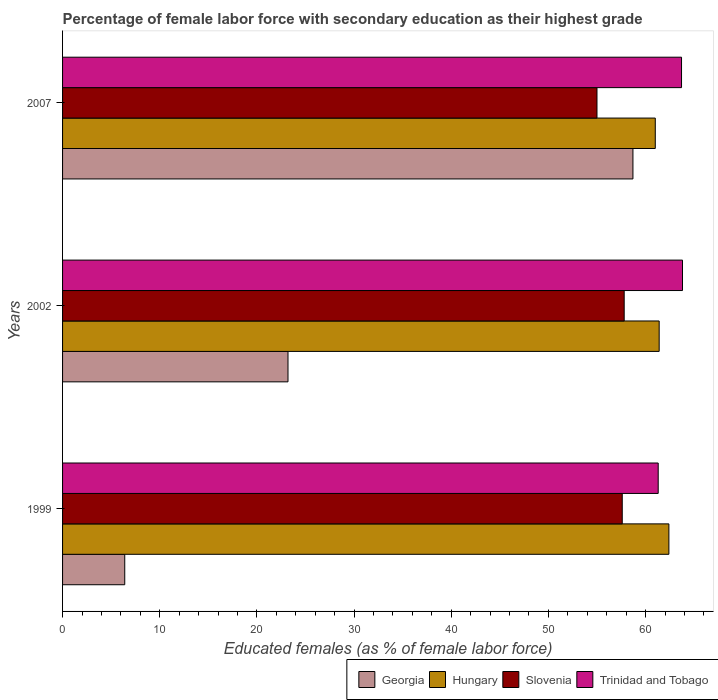How many groups of bars are there?
Your answer should be very brief. 3. Are the number of bars per tick equal to the number of legend labels?
Provide a short and direct response. Yes. Are the number of bars on each tick of the Y-axis equal?
Make the answer very short. Yes. How many bars are there on the 1st tick from the bottom?
Your answer should be compact. 4. What is the percentage of female labor force with secondary education in Trinidad and Tobago in 2007?
Your response must be concise. 63.7. Across all years, what is the maximum percentage of female labor force with secondary education in Hungary?
Your answer should be compact. 62.4. In which year was the percentage of female labor force with secondary education in Slovenia maximum?
Your response must be concise. 2002. What is the total percentage of female labor force with secondary education in Slovenia in the graph?
Provide a succinct answer. 170.4. What is the difference between the percentage of female labor force with secondary education in Hungary in 1999 and that in 2007?
Offer a terse response. 1.4. What is the difference between the percentage of female labor force with secondary education in Slovenia in 2007 and the percentage of female labor force with secondary education in Hungary in 1999?
Give a very brief answer. -7.4. What is the average percentage of female labor force with secondary education in Hungary per year?
Keep it short and to the point. 61.6. In the year 2007, what is the difference between the percentage of female labor force with secondary education in Georgia and percentage of female labor force with secondary education in Slovenia?
Keep it short and to the point. 3.7. What is the ratio of the percentage of female labor force with secondary education in Georgia in 2002 to that in 2007?
Offer a terse response. 0.4. Is the percentage of female labor force with secondary education in Slovenia in 2002 less than that in 2007?
Give a very brief answer. No. What is the difference between the highest and the second highest percentage of female labor force with secondary education in Slovenia?
Provide a succinct answer. 0.2. In how many years, is the percentage of female labor force with secondary education in Georgia greater than the average percentage of female labor force with secondary education in Georgia taken over all years?
Your answer should be compact. 1. Is the sum of the percentage of female labor force with secondary education in Trinidad and Tobago in 2002 and 2007 greater than the maximum percentage of female labor force with secondary education in Georgia across all years?
Your answer should be very brief. Yes. Is it the case that in every year, the sum of the percentage of female labor force with secondary education in Georgia and percentage of female labor force with secondary education in Hungary is greater than the sum of percentage of female labor force with secondary education in Slovenia and percentage of female labor force with secondary education in Trinidad and Tobago?
Provide a short and direct response. No. What does the 4th bar from the top in 1999 represents?
Offer a very short reply. Georgia. What does the 4th bar from the bottom in 1999 represents?
Give a very brief answer. Trinidad and Tobago. How many bars are there?
Ensure brevity in your answer.  12. Are all the bars in the graph horizontal?
Your answer should be compact. Yes. How many years are there in the graph?
Keep it short and to the point. 3. What is the difference between two consecutive major ticks on the X-axis?
Keep it short and to the point. 10. Are the values on the major ticks of X-axis written in scientific E-notation?
Make the answer very short. No. Where does the legend appear in the graph?
Give a very brief answer. Bottom right. How many legend labels are there?
Ensure brevity in your answer.  4. How are the legend labels stacked?
Offer a terse response. Horizontal. What is the title of the graph?
Your answer should be very brief. Percentage of female labor force with secondary education as their highest grade. Does "Cyprus" appear as one of the legend labels in the graph?
Provide a succinct answer. No. What is the label or title of the X-axis?
Your response must be concise. Educated females (as % of female labor force). What is the label or title of the Y-axis?
Your answer should be very brief. Years. What is the Educated females (as % of female labor force) in Georgia in 1999?
Provide a short and direct response. 6.4. What is the Educated females (as % of female labor force) of Hungary in 1999?
Provide a short and direct response. 62.4. What is the Educated females (as % of female labor force) of Slovenia in 1999?
Provide a short and direct response. 57.6. What is the Educated females (as % of female labor force) of Trinidad and Tobago in 1999?
Your answer should be very brief. 61.3. What is the Educated females (as % of female labor force) in Georgia in 2002?
Give a very brief answer. 23.2. What is the Educated females (as % of female labor force) of Hungary in 2002?
Offer a terse response. 61.4. What is the Educated females (as % of female labor force) in Slovenia in 2002?
Provide a succinct answer. 57.8. What is the Educated females (as % of female labor force) of Trinidad and Tobago in 2002?
Provide a short and direct response. 63.8. What is the Educated females (as % of female labor force) of Georgia in 2007?
Provide a short and direct response. 58.7. What is the Educated females (as % of female labor force) of Trinidad and Tobago in 2007?
Give a very brief answer. 63.7. Across all years, what is the maximum Educated females (as % of female labor force) in Georgia?
Give a very brief answer. 58.7. Across all years, what is the maximum Educated females (as % of female labor force) in Hungary?
Make the answer very short. 62.4. Across all years, what is the maximum Educated females (as % of female labor force) in Slovenia?
Your answer should be compact. 57.8. Across all years, what is the maximum Educated females (as % of female labor force) of Trinidad and Tobago?
Provide a succinct answer. 63.8. Across all years, what is the minimum Educated females (as % of female labor force) of Georgia?
Provide a short and direct response. 6.4. Across all years, what is the minimum Educated females (as % of female labor force) of Hungary?
Provide a succinct answer. 61. Across all years, what is the minimum Educated females (as % of female labor force) of Slovenia?
Your answer should be very brief. 55. Across all years, what is the minimum Educated females (as % of female labor force) in Trinidad and Tobago?
Provide a short and direct response. 61.3. What is the total Educated females (as % of female labor force) of Georgia in the graph?
Your answer should be very brief. 88.3. What is the total Educated females (as % of female labor force) in Hungary in the graph?
Your answer should be compact. 184.8. What is the total Educated females (as % of female labor force) in Slovenia in the graph?
Your answer should be compact. 170.4. What is the total Educated females (as % of female labor force) in Trinidad and Tobago in the graph?
Your answer should be compact. 188.8. What is the difference between the Educated females (as % of female labor force) of Georgia in 1999 and that in 2002?
Keep it short and to the point. -16.8. What is the difference between the Educated females (as % of female labor force) in Georgia in 1999 and that in 2007?
Offer a very short reply. -52.3. What is the difference between the Educated females (as % of female labor force) in Trinidad and Tobago in 1999 and that in 2007?
Your answer should be compact. -2.4. What is the difference between the Educated females (as % of female labor force) in Georgia in 2002 and that in 2007?
Keep it short and to the point. -35.5. What is the difference between the Educated females (as % of female labor force) of Slovenia in 2002 and that in 2007?
Your answer should be very brief. 2.8. What is the difference between the Educated females (as % of female labor force) in Trinidad and Tobago in 2002 and that in 2007?
Make the answer very short. 0.1. What is the difference between the Educated females (as % of female labor force) of Georgia in 1999 and the Educated females (as % of female labor force) of Hungary in 2002?
Make the answer very short. -55. What is the difference between the Educated females (as % of female labor force) in Georgia in 1999 and the Educated females (as % of female labor force) in Slovenia in 2002?
Provide a succinct answer. -51.4. What is the difference between the Educated females (as % of female labor force) of Georgia in 1999 and the Educated females (as % of female labor force) of Trinidad and Tobago in 2002?
Offer a terse response. -57.4. What is the difference between the Educated females (as % of female labor force) in Hungary in 1999 and the Educated females (as % of female labor force) in Trinidad and Tobago in 2002?
Give a very brief answer. -1.4. What is the difference between the Educated females (as % of female labor force) in Georgia in 1999 and the Educated females (as % of female labor force) in Hungary in 2007?
Keep it short and to the point. -54.6. What is the difference between the Educated females (as % of female labor force) of Georgia in 1999 and the Educated females (as % of female labor force) of Slovenia in 2007?
Offer a very short reply. -48.6. What is the difference between the Educated females (as % of female labor force) in Georgia in 1999 and the Educated females (as % of female labor force) in Trinidad and Tobago in 2007?
Provide a succinct answer. -57.3. What is the difference between the Educated females (as % of female labor force) in Hungary in 1999 and the Educated females (as % of female labor force) in Slovenia in 2007?
Provide a succinct answer. 7.4. What is the difference between the Educated females (as % of female labor force) of Georgia in 2002 and the Educated females (as % of female labor force) of Hungary in 2007?
Provide a succinct answer. -37.8. What is the difference between the Educated females (as % of female labor force) of Georgia in 2002 and the Educated females (as % of female labor force) of Slovenia in 2007?
Provide a short and direct response. -31.8. What is the difference between the Educated females (as % of female labor force) in Georgia in 2002 and the Educated females (as % of female labor force) in Trinidad and Tobago in 2007?
Your response must be concise. -40.5. What is the difference between the Educated females (as % of female labor force) in Hungary in 2002 and the Educated females (as % of female labor force) in Trinidad and Tobago in 2007?
Your answer should be very brief. -2.3. What is the difference between the Educated females (as % of female labor force) of Slovenia in 2002 and the Educated females (as % of female labor force) of Trinidad and Tobago in 2007?
Offer a terse response. -5.9. What is the average Educated females (as % of female labor force) in Georgia per year?
Give a very brief answer. 29.43. What is the average Educated females (as % of female labor force) of Hungary per year?
Your response must be concise. 61.6. What is the average Educated females (as % of female labor force) of Slovenia per year?
Make the answer very short. 56.8. What is the average Educated females (as % of female labor force) in Trinidad and Tobago per year?
Provide a succinct answer. 62.93. In the year 1999, what is the difference between the Educated females (as % of female labor force) in Georgia and Educated females (as % of female labor force) in Hungary?
Your answer should be compact. -56. In the year 1999, what is the difference between the Educated females (as % of female labor force) in Georgia and Educated females (as % of female labor force) in Slovenia?
Give a very brief answer. -51.2. In the year 1999, what is the difference between the Educated females (as % of female labor force) of Georgia and Educated females (as % of female labor force) of Trinidad and Tobago?
Your answer should be very brief. -54.9. In the year 1999, what is the difference between the Educated females (as % of female labor force) of Slovenia and Educated females (as % of female labor force) of Trinidad and Tobago?
Ensure brevity in your answer.  -3.7. In the year 2002, what is the difference between the Educated females (as % of female labor force) in Georgia and Educated females (as % of female labor force) in Hungary?
Give a very brief answer. -38.2. In the year 2002, what is the difference between the Educated females (as % of female labor force) of Georgia and Educated females (as % of female labor force) of Slovenia?
Give a very brief answer. -34.6. In the year 2002, what is the difference between the Educated females (as % of female labor force) in Georgia and Educated females (as % of female labor force) in Trinidad and Tobago?
Provide a succinct answer. -40.6. In the year 2002, what is the difference between the Educated females (as % of female labor force) of Hungary and Educated females (as % of female labor force) of Slovenia?
Keep it short and to the point. 3.6. In the year 2007, what is the difference between the Educated females (as % of female labor force) of Georgia and Educated females (as % of female labor force) of Hungary?
Keep it short and to the point. -2.3. What is the ratio of the Educated females (as % of female labor force) of Georgia in 1999 to that in 2002?
Provide a short and direct response. 0.28. What is the ratio of the Educated females (as % of female labor force) in Hungary in 1999 to that in 2002?
Give a very brief answer. 1.02. What is the ratio of the Educated females (as % of female labor force) of Trinidad and Tobago in 1999 to that in 2002?
Ensure brevity in your answer.  0.96. What is the ratio of the Educated females (as % of female labor force) of Georgia in 1999 to that in 2007?
Offer a terse response. 0.11. What is the ratio of the Educated females (as % of female labor force) of Hungary in 1999 to that in 2007?
Give a very brief answer. 1.02. What is the ratio of the Educated females (as % of female labor force) in Slovenia in 1999 to that in 2007?
Your response must be concise. 1.05. What is the ratio of the Educated females (as % of female labor force) in Trinidad and Tobago in 1999 to that in 2007?
Ensure brevity in your answer.  0.96. What is the ratio of the Educated females (as % of female labor force) of Georgia in 2002 to that in 2007?
Your answer should be compact. 0.4. What is the ratio of the Educated females (as % of female labor force) in Hungary in 2002 to that in 2007?
Offer a terse response. 1.01. What is the ratio of the Educated females (as % of female labor force) in Slovenia in 2002 to that in 2007?
Your answer should be compact. 1.05. What is the difference between the highest and the second highest Educated females (as % of female labor force) of Georgia?
Provide a short and direct response. 35.5. What is the difference between the highest and the second highest Educated females (as % of female labor force) of Hungary?
Your answer should be compact. 1. What is the difference between the highest and the second highest Educated females (as % of female labor force) in Slovenia?
Offer a very short reply. 0.2. What is the difference between the highest and the lowest Educated females (as % of female labor force) of Georgia?
Keep it short and to the point. 52.3. What is the difference between the highest and the lowest Educated females (as % of female labor force) of Hungary?
Your response must be concise. 1.4. 